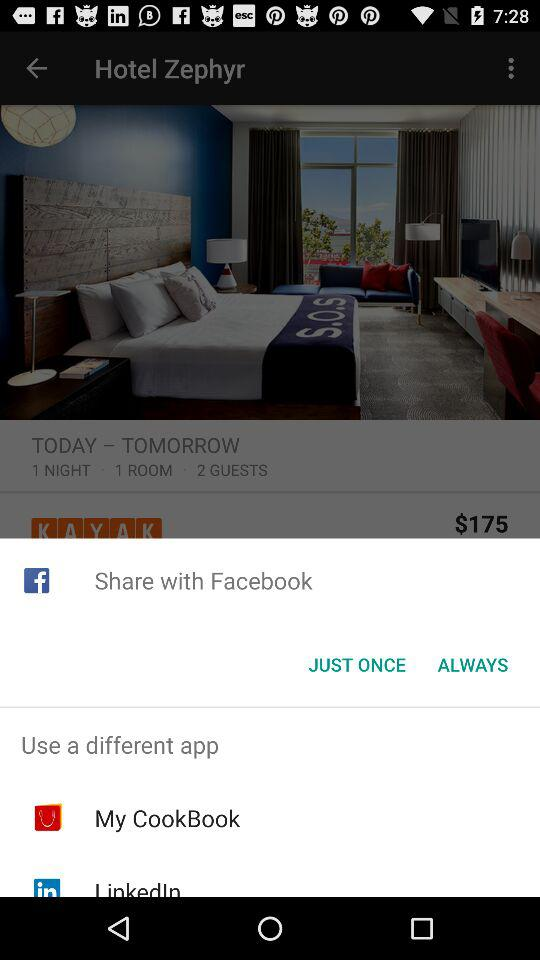How many more guests are there than rooms?
Answer the question using a single word or phrase. 1 